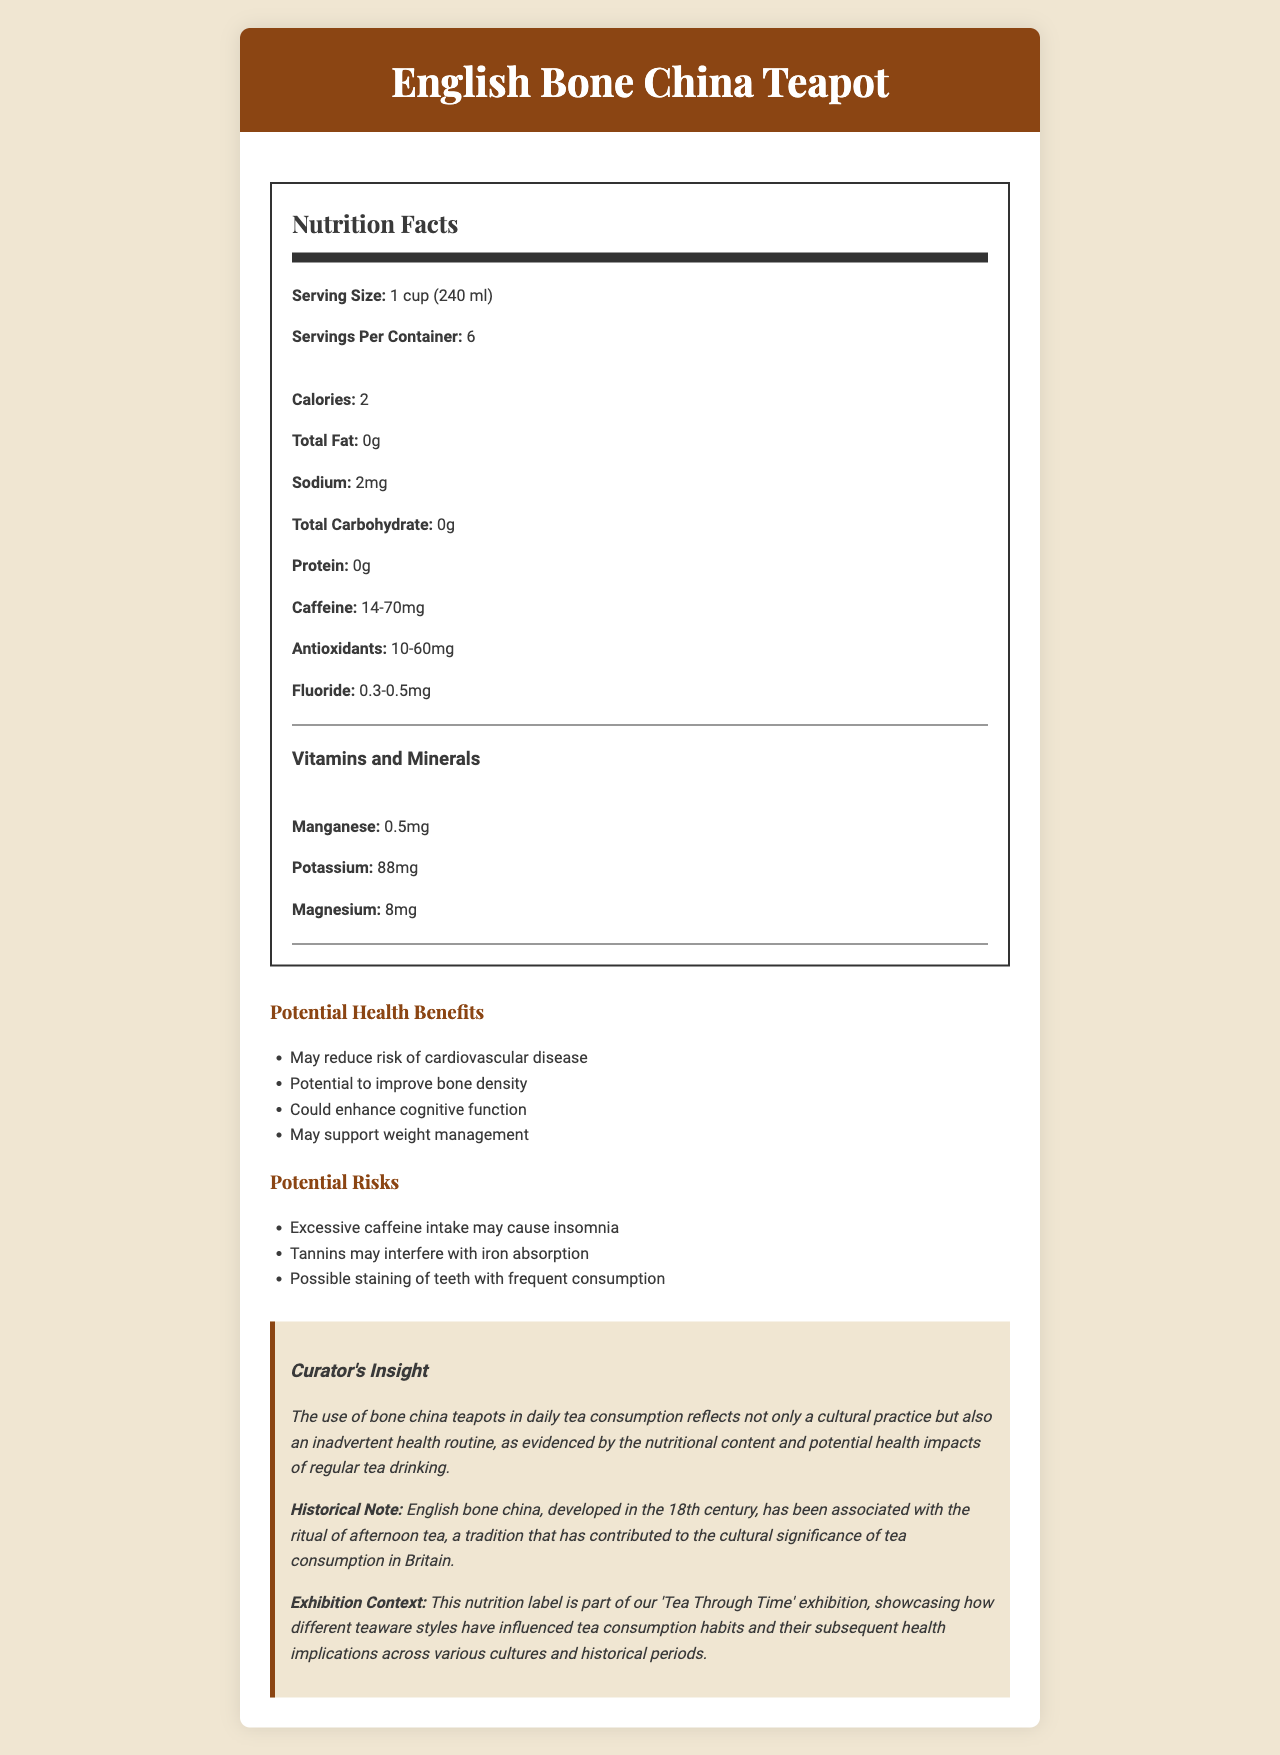what is the serving size for the English Bone China Teapot? The serving size is clearly specified as 1 cup (240 ml) in the document.
Answer: 1 cup (240 ml) how many servings are contained in one English Bone China Teapot? The document states that there are 6 servings per container.
Answer: 6 what is the calorie count per serving of tea from the English Bone China Teapot? The nutrition facts section lists 2 calories per serving.
Answer: 2 calories how much caffeine does one serving of tea contain? The caffeine content per serving varies between 14 to 70mg.
Answer: 14-70mg what are the health benefits of daily tea consumption from the English Bone China Teapot? The document lists these specific potential health benefits.
Answer: May reduce risk of cardiovascular disease, Potential to improve bone density, Could enhance cognitive function, May support weight management which mineral is present in the highest amount in one serving of tea? A. Manganese B. Potassium C. Magnesium The content of potassium in one serving is 88mg, which is higher than manganese (0.5mg) and magnesium (8mg).
Answer: B. Potassium which of the following is a potential risk of frequent tea consumption? A. Reduced cognitive function B. Excessive caffeine intake causing insomnia C. High carbohydrate content One of the listed potential risks is that excessive caffeine intake may cause insomnia.
Answer: B. Excessive caffeine intake causing insomnia is the use of English bone china teapots historically significant? The historical note mentions that English bone china, developed in the 18th century, has been associated with the ritual of afternoon tea, a significant cultural practice in Britain.
Answer: Yes how should the vitamins and minerals section be summarized? The vitamins and minerals section lists the amounts of manganese (0.5mg), potassium (88mg), and magnesium (8mg).
Answer: The tea provides small amounts of manganese, potassium, and magnesium. what kind of routine does the curator believe the use of bone china teapots contribute to? The curator's insight specifically mentions that the use of bone china teapots reflects an inadvertent health routine.
Answer: An inadvertent health routine what are the possible effects of tannins in tea? The potential risks section notes that tannins may interfere with iron absorption.
Answer: Interfere with iron absorption describe the main idea of the document The document merges nutritional information with historical and cultural insights, underlining the benefits and risks of tea consumption from an English Bone China Teapot.
Answer: This document provides detailed nutrition facts about tea brewed in an English Bone China Teapot, highlighting its potential health benefits and risks, and emphasizing its historical and cultural significance. how were the antioxidant levels measured? The document does not specify how the antioxidant levels were measured.
Answer: Not enough information 